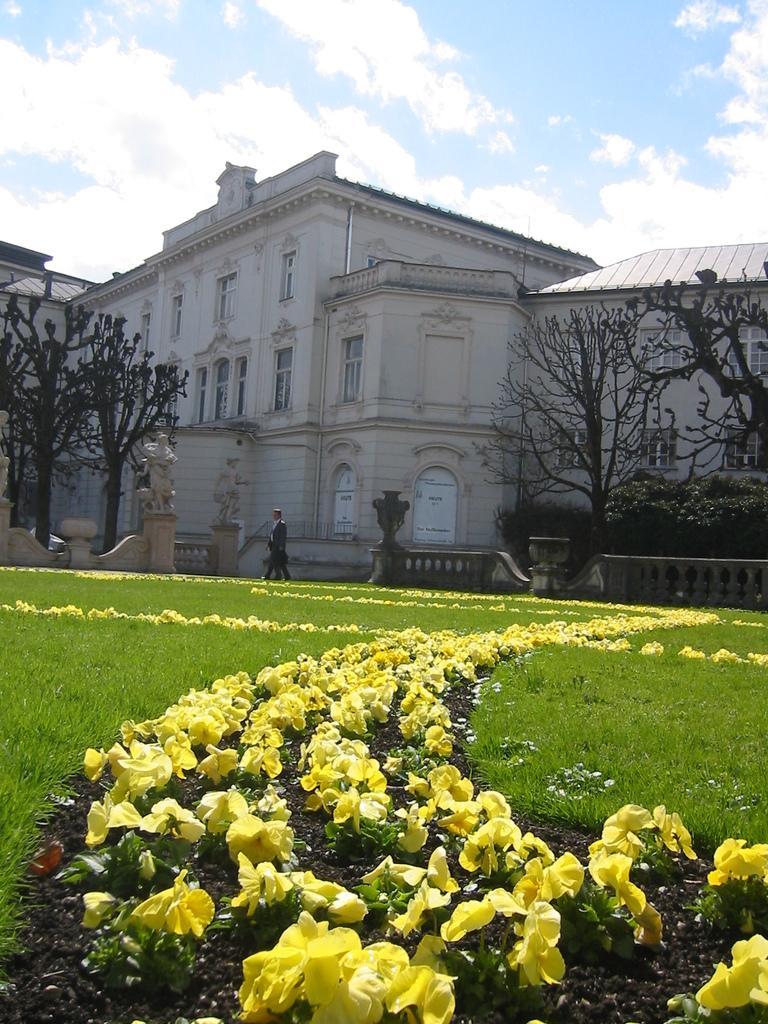Describe this image in one or two sentences. In this image we can see a building with windows, door and a roof. We can also see some grass, plants with flowers, trees, the statues, a fence, two persons standing in the sky which looks cloudy. 